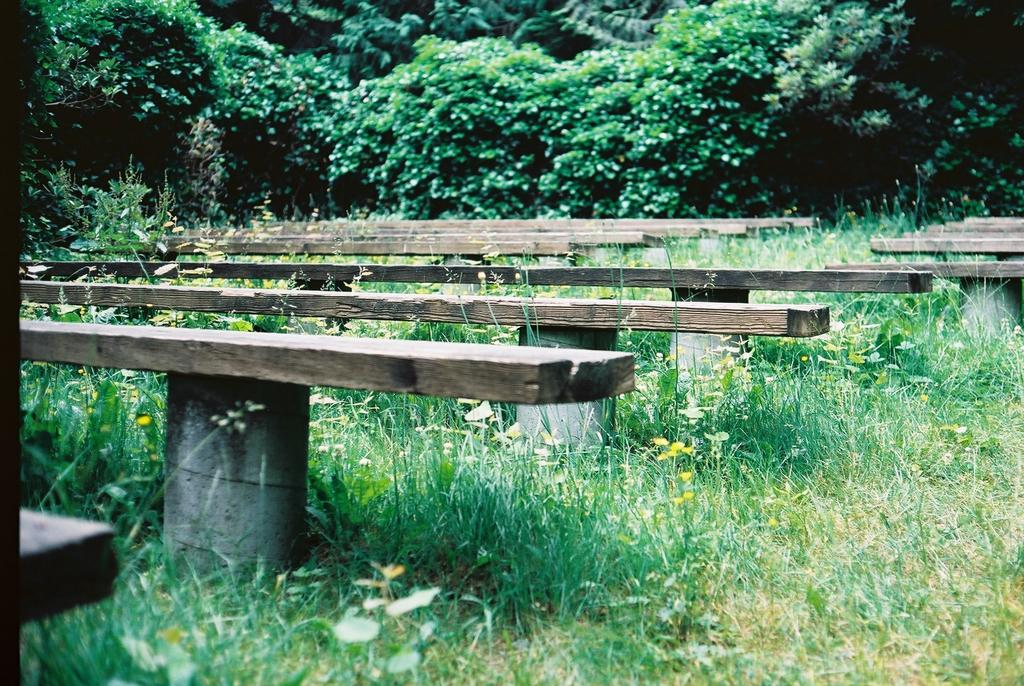What type of seating is present in the image? There are benches with pillars in the image. What type of vegetation can be seen in the image? There is grass, flowers, plants, and trees in the image. Where are the trees located in the image? The trees are in the background of the image. Can you see any pigs running through the grass in the image? There are no pigs present in the image; it features benches, pillars, grass, flowers, plants, and trees. Is your aunt sitting on one of the benches in the image? There is no information about your aunt in the image, as it only shows benches, pillars, grass, flowers, plants, and trees. 